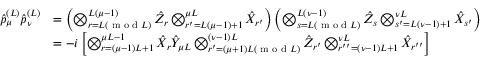Convert formula to latex. <formula><loc_0><loc_0><loc_500><loc_500>\begin{array} { r l } { \hat { p } _ { \mu } ^ { ( L ) } \hat { p } _ { \nu } ^ { ( L ) } } & { = \left ( \bigotimes _ { r = L ( m o d L ) } ^ { L ( \mu - 1 ) } \hat { Z } _ { r } \bigotimes _ { r ^ { \prime } = L ( \mu - 1 ) + 1 } ^ { \mu L } \hat { X } _ { r ^ { \prime } } \right ) \left ( \bigotimes _ { s = L ( m o d L ) } ^ { L ( \nu - 1 ) } \hat { Z } _ { s } \bigotimes _ { s ^ { \prime } = L ( \nu - 1 ) + 1 } ^ { \nu L } \hat { X } _ { s ^ { \prime } } \right ) } \\ & { = - i \left [ \bigotimes _ { r = ( \mu - 1 ) L + 1 } ^ { \mu L - 1 } \hat { X } _ { r } \hat { Y } _ { \mu L } \bigotimes _ { r ^ { \prime } = ( \mu + 1 ) L ( m o d L ) } ^ { ( \nu - 1 ) L } \hat { Z } _ { r ^ { \prime } } \bigotimes _ { r ^ { \prime \prime } = ( \nu - 1 ) L + 1 } ^ { \nu L } \hat { X } _ { r ^ { \prime \prime } } \right ] } \end{array}</formula> 